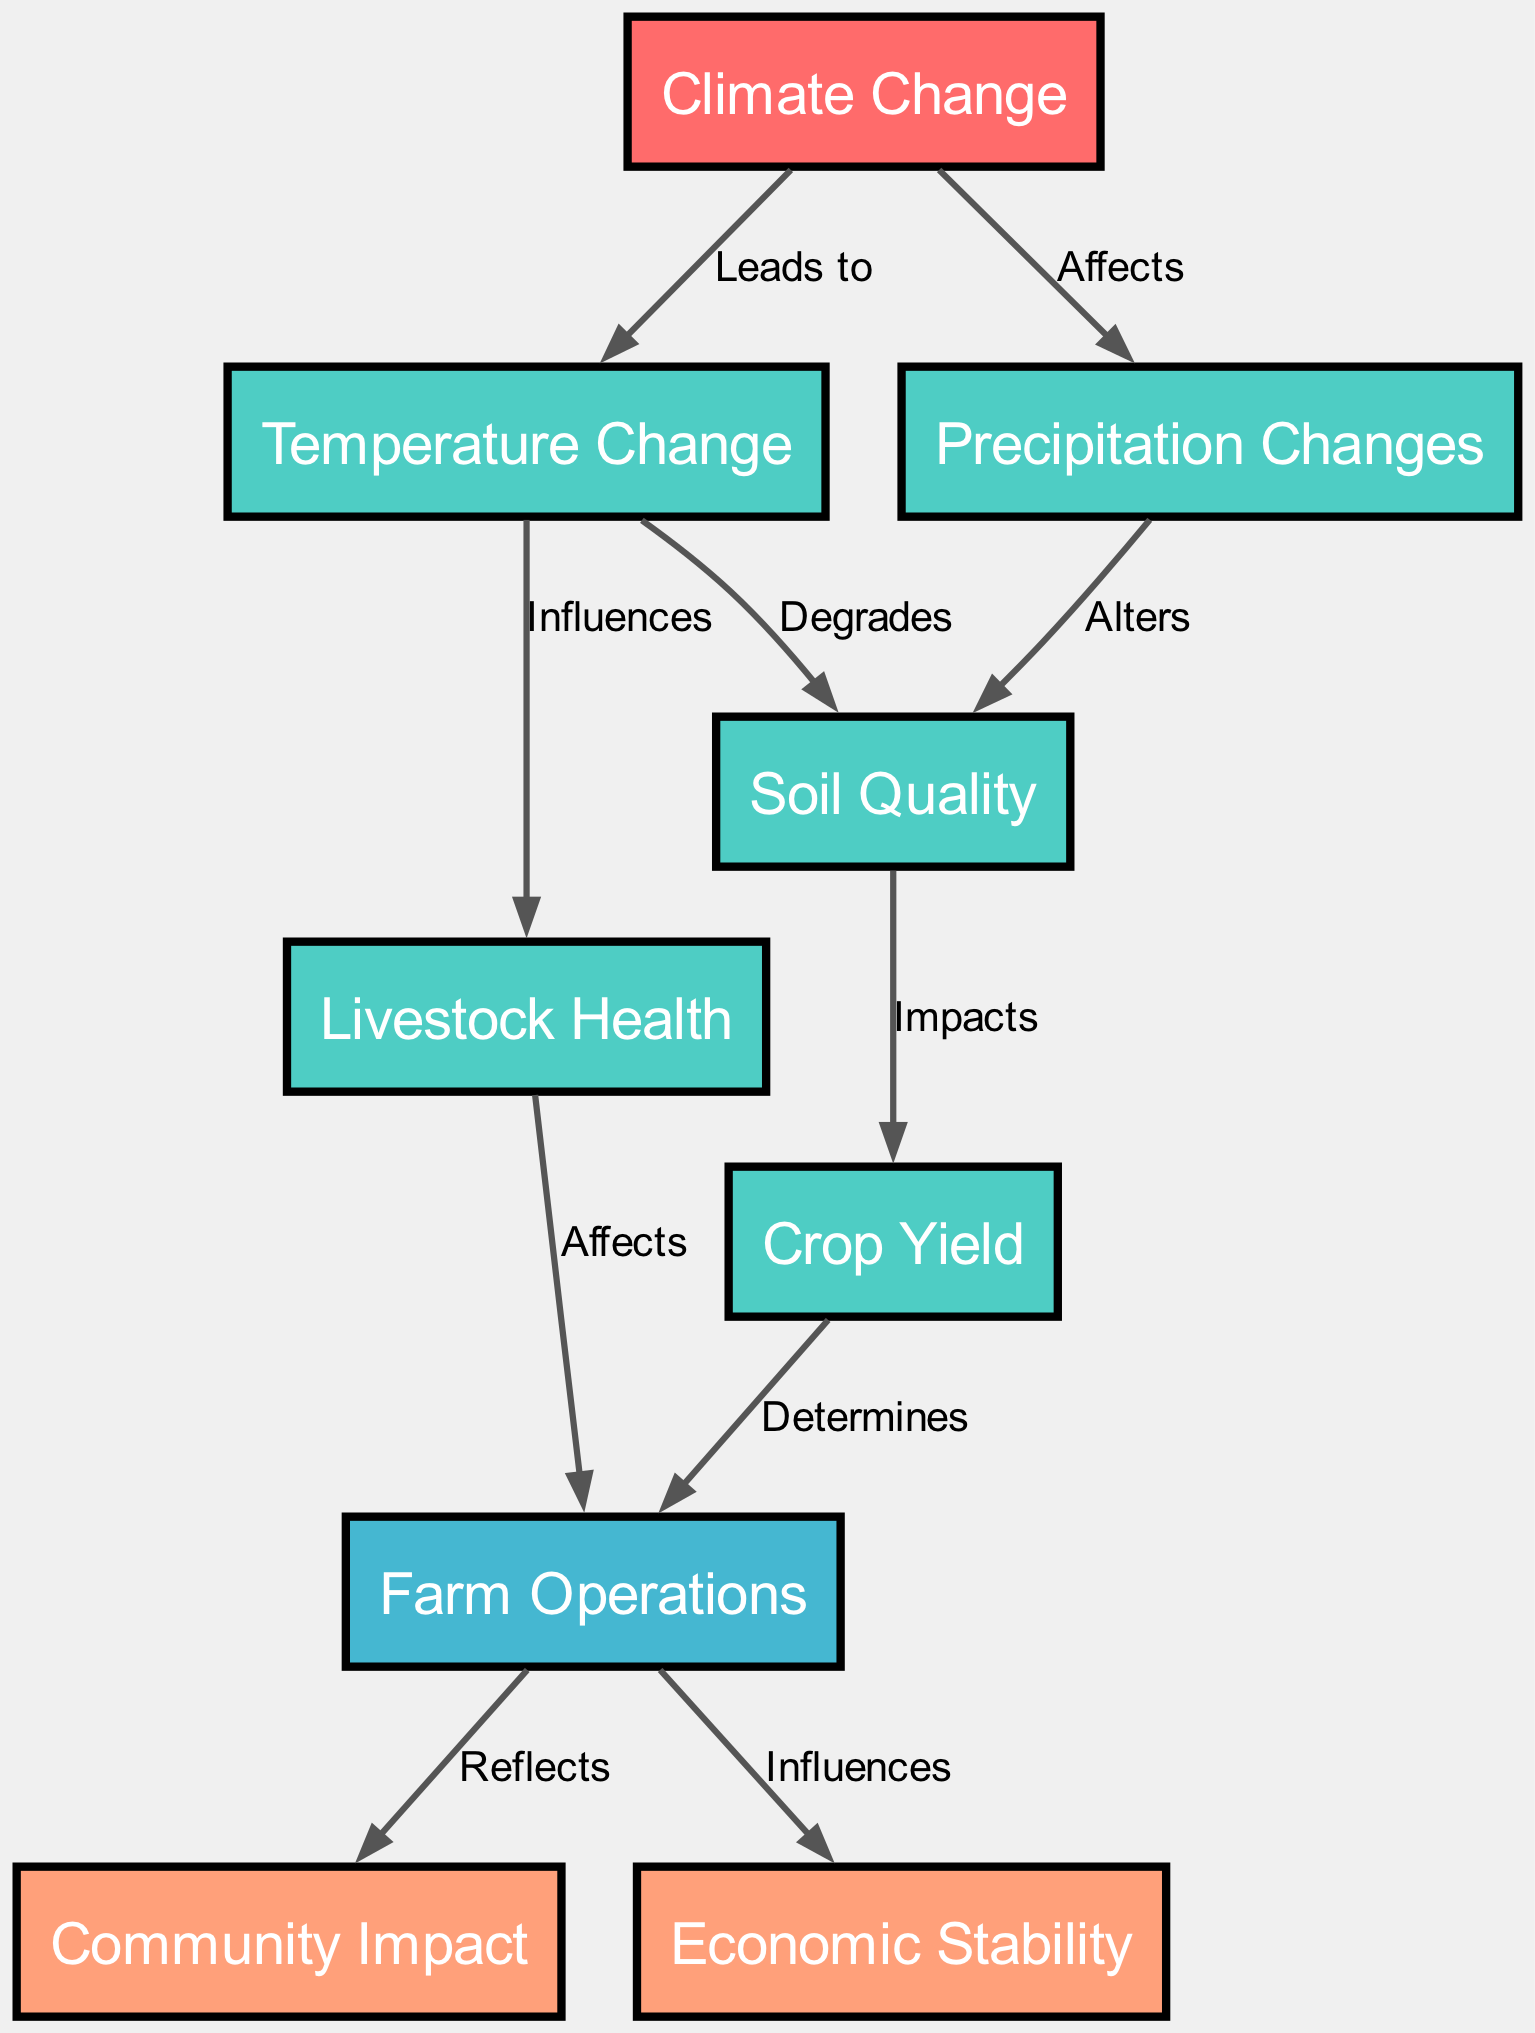What is the main cause in the diagram? The main cause is identified in the diagram as the "Climate Change" node, which initiates the changes influencing the agricultural supply chain.
Answer: Climate Change How many effects are listed in the diagram? By counting the nodes categorized as effects, we find four: "Temperature Change," "Precipitation Changes," "Soil Quality," "Crop Yield," and "Livestock Health." Therefore, there are five effects.
Answer: Five What does temperature change degrade? According to the diagram, the change in temperature is shown to degrade "Soil Quality," indicating its negative impact on the land's fertility.
Answer: Soil Quality Which outcome is influenced by farm operations? The diagram indicates that the nodes "Community Impact" and "Economic Stability" are outcomes influenced by "Farm Operations," meaning farmers' practices affect both these aspects.
Answer: Community Impact, Economic Stability What relationship exists between livestock health and farm operations? The diagram highlights that livestock health "Affects" farm operations, meaning that the well-being of livestock plays a role in how farms are operated effectively.
Answer: Affects What node does precipitation change alter? The diagram clearly states that precipitation changes "Alters" the soil quality, showcasing its significant role in determining the health of the land.
Answer: Soil Quality Which factors impact crop yield according to the diagram? The diagram shows that both "Soil Quality" and "Temperature Change" impact crop yield, implying that these conditions are crucial for determining the outputs of crop production.
Answer: Soil Quality, Temperature Change What flows from temperature change to livestock health? The relationship depicted shows that temperature changes "Influences" livestock health, indicating how shifts in climate can directly affect the well-being of animals on the farm.
Answer: Influences 